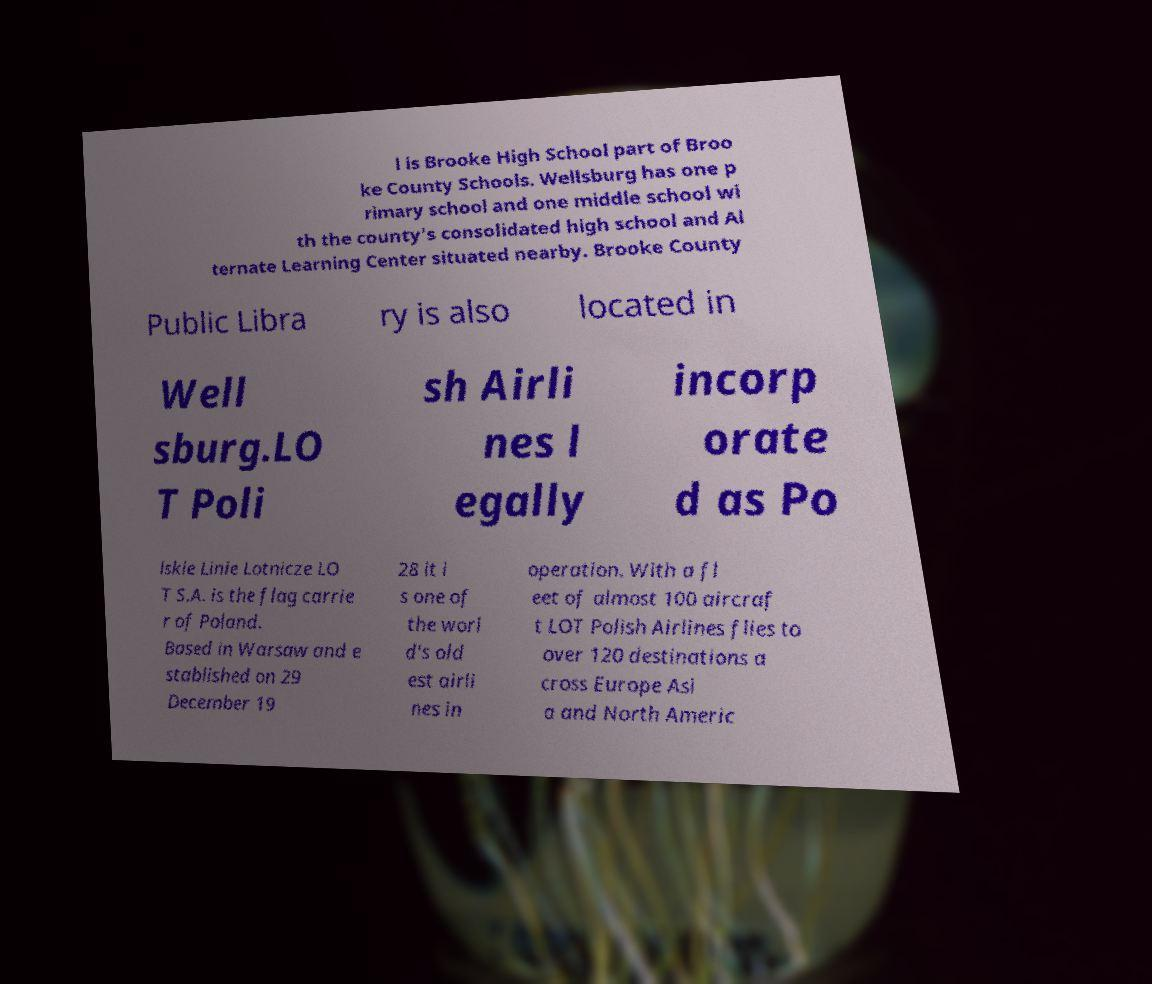Could you assist in decoding the text presented in this image and type it out clearly? l is Brooke High School part of Broo ke County Schools. Wellsburg has one p rimary school and one middle school wi th the county's consolidated high school and Al ternate Learning Center situated nearby. Brooke County Public Libra ry is also located in Well sburg.LO T Poli sh Airli nes l egally incorp orate d as Po lskie Linie Lotnicze LO T S.A. is the flag carrie r of Poland. Based in Warsaw and e stablished on 29 December 19 28 it i s one of the worl d's old est airli nes in operation. With a fl eet of almost 100 aircraf t LOT Polish Airlines flies to over 120 destinations a cross Europe Asi a and North Americ 